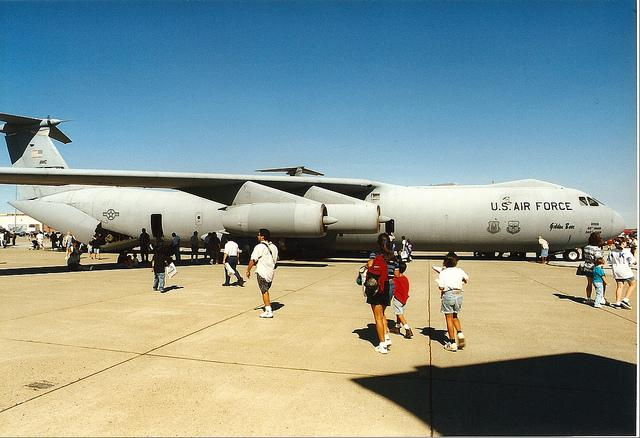What type of military individual fly's this plane? air force 